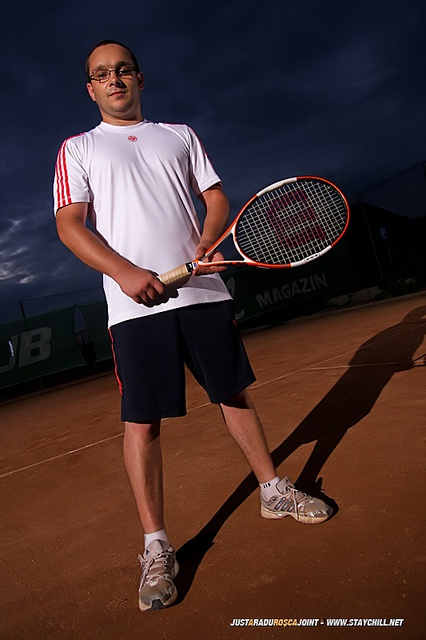Describe the objects in this image and their specific colors. I can see people in black, lavender, brown, and maroon tones and tennis racket in black, gray, maroon, and brown tones in this image. 